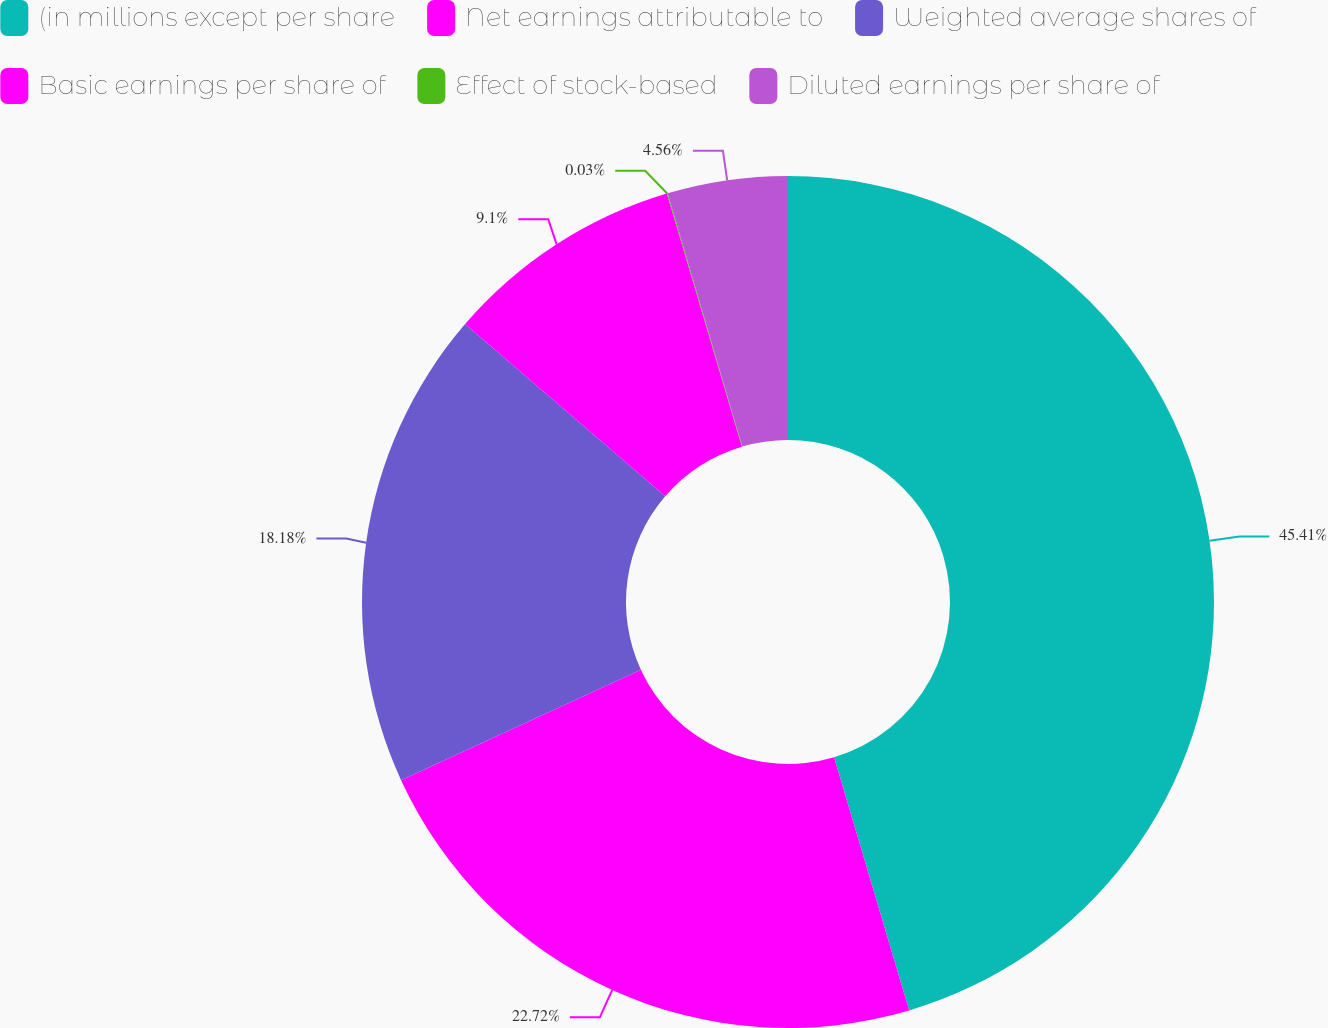<chart> <loc_0><loc_0><loc_500><loc_500><pie_chart><fcel>(in millions except per share<fcel>Net earnings attributable to<fcel>Weighted average shares of<fcel>Basic earnings per share of<fcel>Effect of stock-based<fcel>Diluted earnings per share of<nl><fcel>45.41%<fcel>22.72%<fcel>18.18%<fcel>9.1%<fcel>0.03%<fcel>4.56%<nl></chart> 